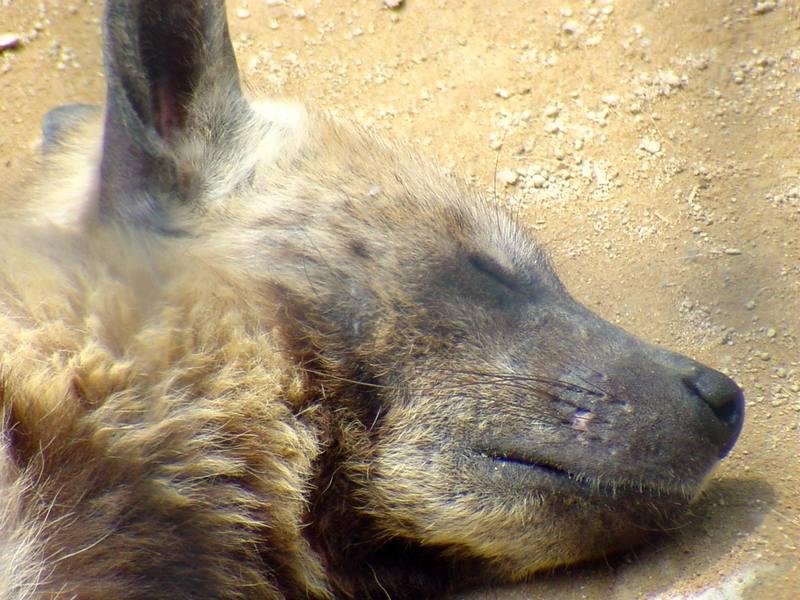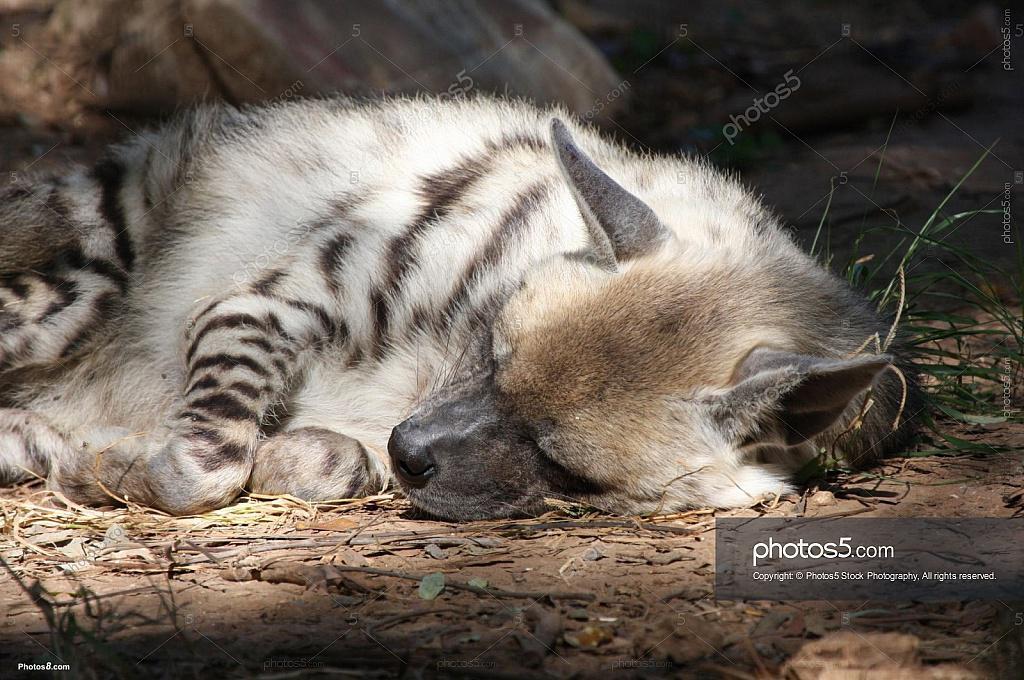The first image is the image on the left, the second image is the image on the right. Analyze the images presented: Is the assertion "At least one animal is resting underneath of a rocky covering." valid? Answer yes or no. No. The first image is the image on the left, the second image is the image on the right. Considering the images on both sides, is "There are exactly two sleeping hyenas." valid? Answer yes or no. Yes. 